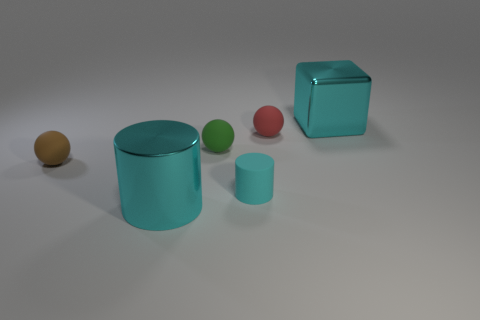What is the size of the other cylinder that is the same color as the matte cylinder?
Your response must be concise. Large. How many small things are behind the large cyan object that is left of the big cyan block?
Offer a terse response. 4. How many other objects are the same size as the red rubber object?
Keep it short and to the point. 3. Is the color of the metal cylinder the same as the large metallic cube?
Your answer should be very brief. Yes. Is the shape of the cyan shiny thing behind the matte cylinder the same as  the tiny red thing?
Offer a very short reply. No. How many things are behind the brown matte ball and on the left side of the tiny green ball?
Your answer should be very brief. 0. What is the large cyan cylinder made of?
Ensure brevity in your answer.  Metal. Is there any other thing of the same color as the large cube?
Your response must be concise. Yes. Do the red object and the green object have the same material?
Your response must be concise. Yes. What number of tiny cyan matte cylinders are in front of the big thing in front of the brown rubber ball in front of the tiny green object?
Make the answer very short. 0. 